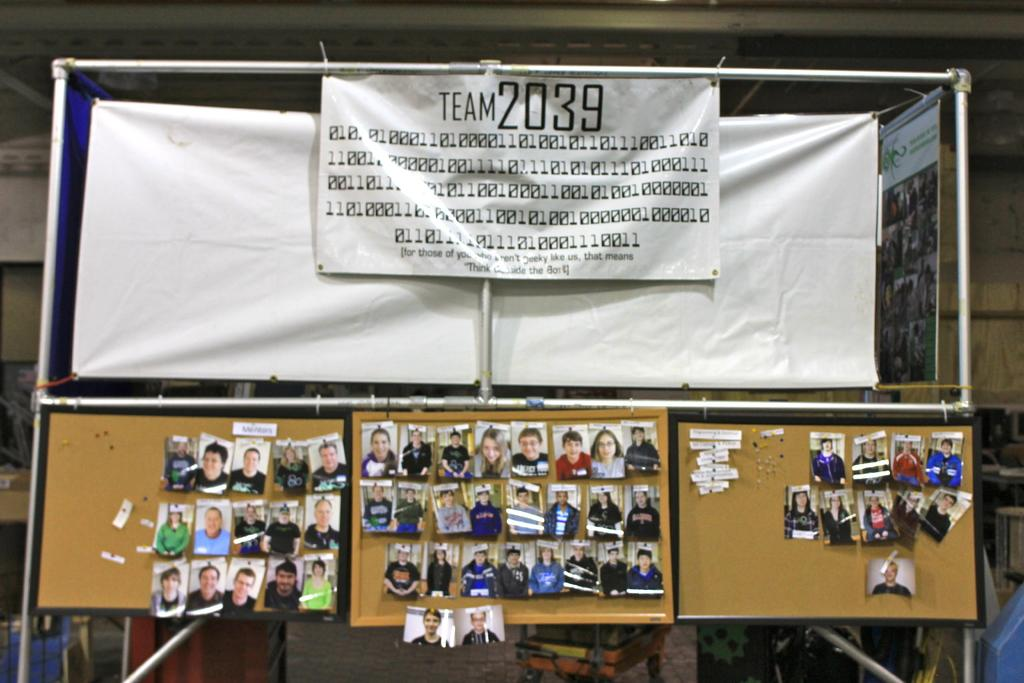<image>
Give a short and clear explanation of the subsequent image. a bulletin board with pictures of team 2039 on the banner.. 